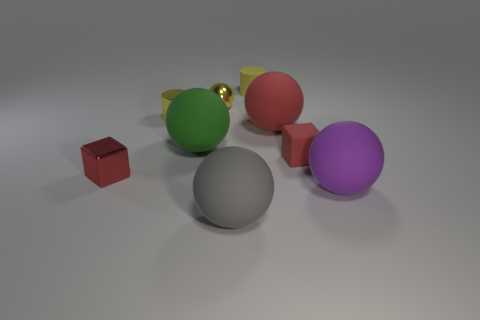Subtract all red balls. How many balls are left? 4 Subtract all purple spheres. How many spheres are left? 4 Subtract all brown spheres. Subtract all red cylinders. How many spheres are left? 5 Add 1 big gray rubber objects. How many objects exist? 10 Subtract all cubes. How many objects are left? 7 Subtract 1 green spheres. How many objects are left? 8 Subtract all tiny red metal objects. Subtract all green rubber balls. How many objects are left? 7 Add 2 red metallic things. How many red metallic things are left? 3 Add 3 large purple objects. How many large purple objects exist? 4 